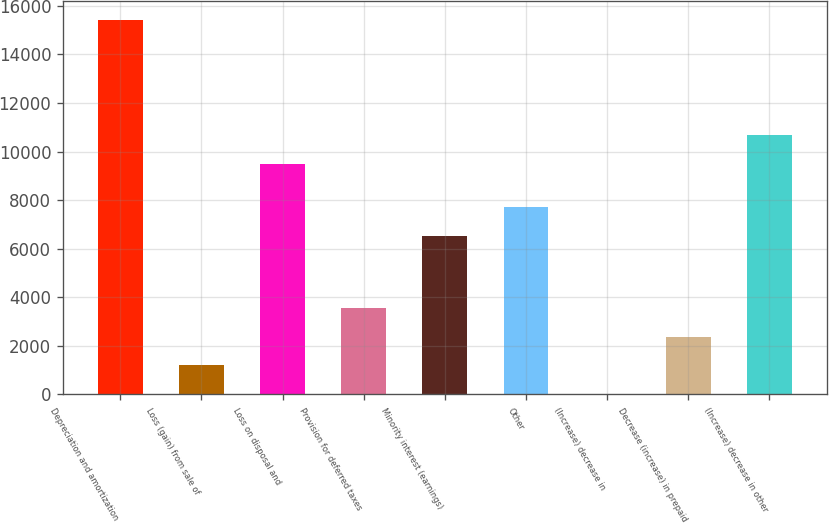<chart> <loc_0><loc_0><loc_500><loc_500><bar_chart><fcel>Depreciation and amortization<fcel>Loss (gain) from sale of<fcel>Loss on disposal and<fcel>Provision for deferred taxes<fcel>Minority interest (earnings)<fcel>Other<fcel>(Increase) decrease in<fcel>Decrease (increase) in prepaid<fcel>(Increase) decrease in other<nl><fcel>15415<fcel>1195<fcel>9490<fcel>3565<fcel>6527.5<fcel>7712.5<fcel>10<fcel>2380<fcel>10675<nl></chart> 